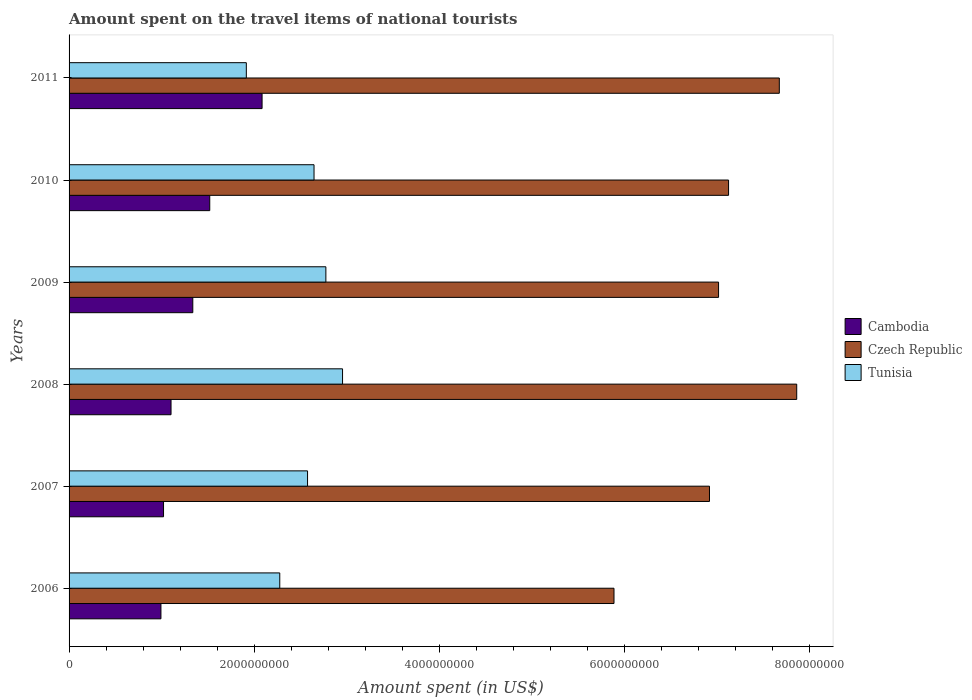How many groups of bars are there?
Ensure brevity in your answer.  6. Are the number of bars on each tick of the Y-axis equal?
Provide a short and direct response. Yes. What is the label of the 4th group of bars from the top?
Give a very brief answer. 2008. In how many cases, is the number of bars for a given year not equal to the number of legend labels?
Make the answer very short. 0. What is the amount spent on the travel items of national tourists in Tunisia in 2010?
Your answer should be compact. 2.64e+09. Across all years, what is the maximum amount spent on the travel items of national tourists in Czech Republic?
Your answer should be compact. 7.86e+09. Across all years, what is the minimum amount spent on the travel items of national tourists in Tunisia?
Your response must be concise. 1.91e+09. In which year was the amount spent on the travel items of national tourists in Tunisia maximum?
Your answer should be very brief. 2008. In which year was the amount spent on the travel items of national tourists in Czech Republic minimum?
Keep it short and to the point. 2006. What is the total amount spent on the travel items of national tourists in Tunisia in the graph?
Your answer should be compact. 1.51e+1. What is the difference between the amount spent on the travel items of national tourists in Tunisia in 2008 and that in 2009?
Your response must be concise. 1.80e+08. What is the difference between the amount spent on the travel items of national tourists in Czech Republic in 2006 and the amount spent on the travel items of national tourists in Tunisia in 2008?
Your response must be concise. 2.93e+09. What is the average amount spent on the travel items of national tourists in Cambodia per year?
Keep it short and to the point. 1.34e+09. In the year 2007, what is the difference between the amount spent on the travel items of national tourists in Cambodia and amount spent on the travel items of national tourists in Czech Republic?
Provide a succinct answer. -5.90e+09. In how many years, is the amount spent on the travel items of national tourists in Czech Republic greater than 4400000000 US$?
Your response must be concise. 6. What is the ratio of the amount spent on the travel items of national tourists in Cambodia in 2006 to that in 2011?
Your answer should be very brief. 0.48. What is the difference between the highest and the second highest amount spent on the travel items of national tourists in Cambodia?
Your answer should be compact. 5.65e+08. What is the difference between the highest and the lowest amount spent on the travel items of national tourists in Cambodia?
Provide a short and direct response. 1.09e+09. In how many years, is the amount spent on the travel items of national tourists in Czech Republic greater than the average amount spent on the travel items of national tourists in Czech Republic taken over all years?
Make the answer very short. 3. Is the sum of the amount spent on the travel items of national tourists in Czech Republic in 2008 and 2010 greater than the maximum amount spent on the travel items of national tourists in Tunisia across all years?
Offer a terse response. Yes. What does the 1st bar from the top in 2006 represents?
Your answer should be compact. Tunisia. What does the 3rd bar from the bottom in 2010 represents?
Make the answer very short. Tunisia. Are the values on the major ticks of X-axis written in scientific E-notation?
Provide a succinct answer. No. Where does the legend appear in the graph?
Your answer should be compact. Center right. How many legend labels are there?
Keep it short and to the point. 3. What is the title of the graph?
Provide a succinct answer. Amount spent on the travel items of national tourists. Does "Guatemala" appear as one of the legend labels in the graph?
Keep it short and to the point. No. What is the label or title of the X-axis?
Keep it short and to the point. Amount spent (in US$). What is the label or title of the Y-axis?
Give a very brief answer. Years. What is the Amount spent (in US$) of Cambodia in 2006?
Keep it short and to the point. 9.92e+08. What is the Amount spent (in US$) in Czech Republic in 2006?
Your response must be concise. 5.88e+09. What is the Amount spent (in US$) in Tunisia in 2006?
Your answer should be compact. 2.28e+09. What is the Amount spent (in US$) in Cambodia in 2007?
Provide a short and direct response. 1.02e+09. What is the Amount spent (in US$) of Czech Republic in 2007?
Keep it short and to the point. 6.92e+09. What is the Amount spent (in US$) in Tunisia in 2007?
Your answer should be compact. 2.58e+09. What is the Amount spent (in US$) in Cambodia in 2008?
Your answer should be compact. 1.10e+09. What is the Amount spent (in US$) in Czech Republic in 2008?
Provide a short and direct response. 7.86e+09. What is the Amount spent (in US$) of Tunisia in 2008?
Offer a very short reply. 2.95e+09. What is the Amount spent (in US$) in Cambodia in 2009?
Keep it short and to the point. 1.34e+09. What is the Amount spent (in US$) in Czech Republic in 2009?
Provide a short and direct response. 7.01e+09. What is the Amount spent (in US$) in Tunisia in 2009?
Make the answer very short. 2.77e+09. What is the Amount spent (in US$) of Cambodia in 2010?
Give a very brief answer. 1.52e+09. What is the Amount spent (in US$) of Czech Republic in 2010?
Ensure brevity in your answer.  7.12e+09. What is the Amount spent (in US$) of Tunisia in 2010?
Offer a very short reply. 2.64e+09. What is the Amount spent (in US$) of Cambodia in 2011?
Keep it short and to the point. 2.08e+09. What is the Amount spent (in US$) in Czech Republic in 2011?
Your answer should be compact. 7.67e+09. What is the Amount spent (in US$) of Tunisia in 2011?
Offer a very short reply. 1.91e+09. Across all years, what is the maximum Amount spent (in US$) of Cambodia?
Ensure brevity in your answer.  2.08e+09. Across all years, what is the maximum Amount spent (in US$) in Czech Republic?
Provide a succinct answer. 7.86e+09. Across all years, what is the maximum Amount spent (in US$) in Tunisia?
Ensure brevity in your answer.  2.95e+09. Across all years, what is the minimum Amount spent (in US$) in Cambodia?
Offer a terse response. 9.92e+08. Across all years, what is the minimum Amount spent (in US$) in Czech Republic?
Keep it short and to the point. 5.88e+09. Across all years, what is the minimum Amount spent (in US$) in Tunisia?
Provide a short and direct response. 1.91e+09. What is the total Amount spent (in US$) in Cambodia in the graph?
Make the answer very short. 8.05e+09. What is the total Amount spent (in US$) in Czech Republic in the graph?
Offer a terse response. 4.25e+1. What is the total Amount spent (in US$) of Tunisia in the graph?
Your answer should be very brief. 1.51e+1. What is the difference between the Amount spent (in US$) in Cambodia in 2006 and that in 2007?
Your answer should be compact. -2.80e+07. What is the difference between the Amount spent (in US$) in Czech Republic in 2006 and that in 2007?
Give a very brief answer. -1.03e+09. What is the difference between the Amount spent (in US$) of Tunisia in 2006 and that in 2007?
Your answer should be very brief. -3.00e+08. What is the difference between the Amount spent (in US$) in Cambodia in 2006 and that in 2008?
Provide a succinct answer. -1.09e+08. What is the difference between the Amount spent (in US$) of Czech Republic in 2006 and that in 2008?
Your response must be concise. -1.97e+09. What is the difference between the Amount spent (in US$) in Tunisia in 2006 and that in 2008?
Provide a succinct answer. -6.78e+08. What is the difference between the Amount spent (in US$) of Cambodia in 2006 and that in 2009?
Your answer should be compact. -3.44e+08. What is the difference between the Amount spent (in US$) in Czech Republic in 2006 and that in 2009?
Offer a terse response. -1.13e+09. What is the difference between the Amount spent (in US$) of Tunisia in 2006 and that in 2009?
Offer a very short reply. -4.98e+08. What is the difference between the Amount spent (in US$) of Cambodia in 2006 and that in 2010?
Ensure brevity in your answer.  -5.27e+08. What is the difference between the Amount spent (in US$) of Czech Republic in 2006 and that in 2010?
Offer a terse response. -1.24e+09. What is the difference between the Amount spent (in US$) in Tunisia in 2006 and that in 2010?
Keep it short and to the point. -3.70e+08. What is the difference between the Amount spent (in US$) of Cambodia in 2006 and that in 2011?
Your answer should be very brief. -1.09e+09. What is the difference between the Amount spent (in US$) of Czech Republic in 2006 and that in 2011?
Give a very brief answer. -1.78e+09. What is the difference between the Amount spent (in US$) in Tunisia in 2006 and that in 2011?
Your answer should be very brief. 3.61e+08. What is the difference between the Amount spent (in US$) of Cambodia in 2007 and that in 2008?
Your answer should be very brief. -8.10e+07. What is the difference between the Amount spent (in US$) of Czech Republic in 2007 and that in 2008?
Offer a very short reply. -9.42e+08. What is the difference between the Amount spent (in US$) of Tunisia in 2007 and that in 2008?
Provide a short and direct response. -3.78e+08. What is the difference between the Amount spent (in US$) in Cambodia in 2007 and that in 2009?
Your response must be concise. -3.16e+08. What is the difference between the Amount spent (in US$) of Czech Republic in 2007 and that in 2009?
Your response must be concise. -9.80e+07. What is the difference between the Amount spent (in US$) of Tunisia in 2007 and that in 2009?
Provide a short and direct response. -1.98e+08. What is the difference between the Amount spent (in US$) in Cambodia in 2007 and that in 2010?
Provide a succinct answer. -4.99e+08. What is the difference between the Amount spent (in US$) of Czech Republic in 2007 and that in 2010?
Offer a very short reply. -2.06e+08. What is the difference between the Amount spent (in US$) of Tunisia in 2007 and that in 2010?
Provide a succinct answer. -7.00e+07. What is the difference between the Amount spent (in US$) of Cambodia in 2007 and that in 2011?
Your answer should be compact. -1.06e+09. What is the difference between the Amount spent (in US$) in Czech Republic in 2007 and that in 2011?
Your answer should be very brief. -7.54e+08. What is the difference between the Amount spent (in US$) of Tunisia in 2007 and that in 2011?
Your response must be concise. 6.61e+08. What is the difference between the Amount spent (in US$) in Cambodia in 2008 and that in 2009?
Keep it short and to the point. -2.35e+08. What is the difference between the Amount spent (in US$) in Czech Republic in 2008 and that in 2009?
Make the answer very short. 8.44e+08. What is the difference between the Amount spent (in US$) of Tunisia in 2008 and that in 2009?
Offer a terse response. 1.80e+08. What is the difference between the Amount spent (in US$) in Cambodia in 2008 and that in 2010?
Offer a very short reply. -4.18e+08. What is the difference between the Amount spent (in US$) of Czech Republic in 2008 and that in 2010?
Your response must be concise. 7.36e+08. What is the difference between the Amount spent (in US$) of Tunisia in 2008 and that in 2010?
Ensure brevity in your answer.  3.08e+08. What is the difference between the Amount spent (in US$) in Cambodia in 2008 and that in 2011?
Make the answer very short. -9.83e+08. What is the difference between the Amount spent (in US$) in Czech Republic in 2008 and that in 2011?
Give a very brief answer. 1.88e+08. What is the difference between the Amount spent (in US$) in Tunisia in 2008 and that in 2011?
Your answer should be very brief. 1.04e+09. What is the difference between the Amount spent (in US$) of Cambodia in 2009 and that in 2010?
Give a very brief answer. -1.83e+08. What is the difference between the Amount spent (in US$) of Czech Republic in 2009 and that in 2010?
Ensure brevity in your answer.  -1.08e+08. What is the difference between the Amount spent (in US$) of Tunisia in 2009 and that in 2010?
Offer a very short reply. 1.28e+08. What is the difference between the Amount spent (in US$) of Cambodia in 2009 and that in 2011?
Make the answer very short. -7.48e+08. What is the difference between the Amount spent (in US$) in Czech Republic in 2009 and that in 2011?
Provide a succinct answer. -6.56e+08. What is the difference between the Amount spent (in US$) in Tunisia in 2009 and that in 2011?
Offer a very short reply. 8.59e+08. What is the difference between the Amount spent (in US$) of Cambodia in 2010 and that in 2011?
Provide a succinct answer. -5.65e+08. What is the difference between the Amount spent (in US$) of Czech Republic in 2010 and that in 2011?
Offer a very short reply. -5.48e+08. What is the difference between the Amount spent (in US$) in Tunisia in 2010 and that in 2011?
Make the answer very short. 7.31e+08. What is the difference between the Amount spent (in US$) in Cambodia in 2006 and the Amount spent (in US$) in Czech Republic in 2007?
Provide a succinct answer. -5.92e+09. What is the difference between the Amount spent (in US$) in Cambodia in 2006 and the Amount spent (in US$) in Tunisia in 2007?
Offer a very short reply. -1.58e+09. What is the difference between the Amount spent (in US$) in Czech Republic in 2006 and the Amount spent (in US$) in Tunisia in 2007?
Ensure brevity in your answer.  3.31e+09. What is the difference between the Amount spent (in US$) in Cambodia in 2006 and the Amount spent (in US$) in Czech Republic in 2008?
Ensure brevity in your answer.  -6.86e+09. What is the difference between the Amount spent (in US$) of Cambodia in 2006 and the Amount spent (in US$) of Tunisia in 2008?
Give a very brief answer. -1.96e+09. What is the difference between the Amount spent (in US$) in Czech Republic in 2006 and the Amount spent (in US$) in Tunisia in 2008?
Your answer should be compact. 2.93e+09. What is the difference between the Amount spent (in US$) of Cambodia in 2006 and the Amount spent (in US$) of Czech Republic in 2009?
Give a very brief answer. -6.02e+09. What is the difference between the Amount spent (in US$) in Cambodia in 2006 and the Amount spent (in US$) in Tunisia in 2009?
Keep it short and to the point. -1.78e+09. What is the difference between the Amount spent (in US$) of Czech Republic in 2006 and the Amount spent (in US$) of Tunisia in 2009?
Your response must be concise. 3.11e+09. What is the difference between the Amount spent (in US$) of Cambodia in 2006 and the Amount spent (in US$) of Czech Republic in 2010?
Provide a short and direct response. -6.13e+09. What is the difference between the Amount spent (in US$) in Cambodia in 2006 and the Amount spent (in US$) in Tunisia in 2010?
Provide a succinct answer. -1.65e+09. What is the difference between the Amount spent (in US$) in Czech Republic in 2006 and the Amount spent (in US$) in Tunisia in 2010?
Offer a very short reply. 3.24e+09. What is the difference between the Amount spent (in US$) of Cambodia in 2006 and the Amount spent (in US$) of Czech Republic in 2011?
Your answer should be compact. -6.68e+09. What is the difference between the Amount spent (in US$) in Cambodia in 2006 and the Amount spent (in US$) in Tunisia in 2011?
Offer a terse response. -9.22e+08. What is the difference between the Amount spent (in US$) of Czech Republic in 2006 and the Amount spent (in US$) of Tunisia in 2011?
Provide a short and direct response. 3.97e+09. What is the difference between the Amount spent (in US$) of Cambodia in 2007 and the Amount spent (in US$) of Czech Republic in 2008?
Your answer should be very brief. -6.84e+09. What is the difference between the Amount spent (in US$) in Cambodia in 2007 and the Amount spent (in US$) in Tunisia in 2008?
Ensure brevity in your answer.  -1.93e+09. What is the difference between the Amount spent (in US$) in Czech Republic in 2007 and the Amount spent (in US$) in Tunisia in 2008?
Your answer should be compact. 3.96e+09. What is the difference between the Amount spent (in US$) of Cambodia in 2007 and the Amount spent (in US$) of Czech Republic in 2009?
Ensure brevity in your answer.  -5.99e+09. What is the difference between the Amount spent (in US$) of Cambodia in 2007 and the Amount spent (in US$) of Tunisia in 2009?
Your answer should be compact. -1.75e+09. What is the difference between the Amount spent (in US$) of Czech Republic in 2007 and the Amount spent (in US$) of Tunisia in 2009?
Your answer should be compact. 4.14e+09. What is the difference between the Amount spent (in US$) of Cambodia in 2007 and the Amount spent (in US$) of Czech Republic in 2010?
Offer a terse response. -6.10e+09. What is the difference between the Amount spent (in US$) of Cambodia in 2007 and the Amount spent (in US$) of Tunisia in 2010?
Offer a very short reply. -1.62e+09. What is the difference between the Amount spent (in US$) in Czech Republic in 2007 and the Amount spent (in US$) in Tunisia in 2010?
Offer a terse response. 4.27e+09. What is the difference between the Amount spent (in US$) in Cambodia in 2007 and the Amount spent (in US$) in Czech Republic in 2011?
Provide a short and direct response. -6.65e+09. What is the difference between the Amount spent (in US$) in Cambodia in 2007 and the Amount spent (in US$) in Tunisia in 2011?
Make the answer very short. -8.94e+08. What is the difference between the Amount spent (in US$) of Czech Republic in 2007 and the Amount spent (in US$) of Tunisia in 2011?
Offer a very short reply. 5.00e+09. What is the difference between the Amount spent (in US$) in Cambodia in 2008 and the Amount spent (in US$) in Czech Republic in 2009?
Your answer should be compact. -5.91e+09. What is the difference between the Amount spent (in US$) in Cambodia in 2008 and the Amount spent (in US$) in Tunisia in 2009?
Your answer should be compact. -1.67e+09. What is the difference between the Amount spent (in US$) of Czech Republic in 2008 and the Amount spent (in US$) of Tunisia in 2009?
Make the answer very short. 5.08e+09. What is the difference between the Amount spent (in US$) of Cambodia in 2008 and the Amount spent (in US$) of Czech Republic in 2010?
Your answer should be compact. -6.02e+09. What is the difference between the Amount spent (in US$) of Cambodia in 2008 and the Amount spent (in US$) of Tunisia in 2010?
Your answer should be very brief. -1.54e+09. What is the difference between the Amount spent (in US$) of Czech Republic in 2008 and the Amount spent (in US$) of Tunisia in 2010?
Offer a terse response. 5.21e+09. What is the difference between the Amount spent (in US$) of Cambodia in 2008 and the Amount spent (in US$) of Czech Republic in 2011?
Make the answer very short. -6.57e+09. What is the difference between the Amount spent (in US$) in Cambodia in 2008 and the Amount spent (in US$) in Tunisia in 2011?
Give a very brief answer. -8.13e+08. What is the difference between the Amount spent (in US$) in Czech Republic in 2008 and the Amount spent (in US$) in Tunisia in 2011?
Your answer should be very brief. 5.94e+09. What is the difference between the Amount spent (in US$) of Cambodia in 2009 and the Amount spent (in US$) of Czech Republic in 2010?
Give a very brief answer. -5.78e+09. What is the difference between the Amount spent (in US$) in Cambodia in 2009 and the Amount spent (in US$) in Tunisia in 2010?
Make the answer very short. -1.31e+09. What is the difference between the Amount spent (in US$) in Czech Republic in 2009 and the Amount spent (in US$) in Tunisia in 2010?
Ensure brevity in your answer.  4.37e+09. What is the difference between the Amount spent (in US$) in Cambodia in 2009 and the Amount spent (in US$) in Czech Republic in 2011?
Offer a terse response. -6.33e+09. What is the difference between the Amount spent (in US$) in Cambodia in 2009 and the Amount spent (in US$) in Tunisia in 2011?
Ensure brevity in your answer.  -5.78e+08. What is the difference between the Amount spent (in US$) of Czech Republic in 2009 and the Amount spent (in US$) of Tunisia in 2011?
Make the answer very short. 5.10e+09. What is the difference between the Amount spent (in US$) in Cambodia in 2010 and the Amount spent (in US$) in Czech Republic in 2011?
Your response must be concise. -6.15e+09. What is the difference between the Amount spent (in US$) in Cambodia in 2010 and the Amount spent (in US$) in Tunisia in 2011?
Offer a very short reply. -3.95e+08. What is the difference between the Amount spent (in US$) in Czech Republic in 2010 and the Amount spent (in US$) in Tunisia in 2011?
Your answer should be compact. 5.21e+09. What is the average Amount spent (in US$) of Cambodia per year?
Offer a very short reply. 1.34e+09. What is the average Amount spent (in US$) of Czech Republic per year?
Make the answer very short. 7.08e+09. What is the average Amount spent (in US$) in Tunisia per year?
Provide a short and direct response. 2.52e+09. In the year 2006, what is the difference between the Amount spent (in US$) of Cambodia and Amount spent (in US$) of Czech Republic?
Offer a terse response. -4.89e+09. In the year 2006, what is the difference between the Amount spent (in US$) of Cambodia and Amount spent (in US$) of Tunisia?
Your answer should be very brief. -1.28e+09. In the year 2006, what is the difference between the Amount spent (in US$) in Czech Republic and Amount spent (in US$) in Tunisia?
Your answer should be very brief. 3.61e+09. In the year 2007, what is the difference between the Amount spent (in US$) of Cambodia and Amount spent (in US$) of Czech Republic?
Ensure brevity in your answer.  -5.90e+09. In the year 2007, what is the difference between the Amount spent (in US$) in Cambodia and Amount spent (in US$) in Tunisia?
Ensure brevity in your answer.  -1.56e+09. In the year 2007, what is the difference between the Amount spent (in US$) in Czech Republic and Amount spent (in US$) in Tunisia?
Your answer should be very brief. 4.34e+09. In the year 2008, what is the difference between the Amount spent (in US$) in Cambodia and Amount spent (in US$) in Czech Republic?
Your response must be concise. -6.76e+09. In the year 2008, what is the difference between the Amount spent (in US$) of Cambodia and Amount spent (in US$) of Tunisia?
Provide a succinct answer. -1.85e+09. In the year 2008, what is the difference between the Amount spent (in US$) of Czech Republic and Amount spent (in US$) of Tunisia?
Keep it short and to the point. 4.90e+09. In the year 2009, what is the difference between the Amount spent (in US$) in Cambodia and Amount spent (in US$) in Czech Republic?
Ensure brevity in your answer.  -5.68e+09. In the year 2009, what is the difference between the Amount spent (in US$) of Cambodia and Amount spent (in US$) of Tunisia?
Give a very brief answer. -1.44e+09. In the year 2009, what is the difference between the Amount spent (in US$) of Czech Republic and Amount spent (in US$) of Tunisia?
Offer a terse response. 4.24e+09. In the year 2010, what is the difference between the Amount spent (in US$) in Cambodia and Amount spent (in US$) in Czech Republic?
Your response must be concise. -5.60e+09. In the year 2010, what is the difference between the Amount spent (in US$) of Cambodia and Amount spent (in US$) of Tunisia?
Offer a terse response. -1.13e+09. In the year 2010, what is the difference between the Amount spent (in US$) in Czech Republic and Amount spent (in US$) in Tunisia?
Make the answer very short. 4.48e+09. In the year 2011, what is the difference between the Amount spent (in US$) of Cambodia and Amount spent (in US$) of Czech Republic?
Offer a very short reply. -5.58e+09. In the year 2011, what is the difference between the Amount spent (in US$) of Cambodia and Amount spent (in US$) of Tunisia?
Your answer should be compact. 1.70e+08. In the year 2011, what is the difference between the Amount spent (in US$) in Czech Republic and Amount spent (in US$) in Tunisia?
Your response must be concise. 5.76e+09. What is the ratio of the Amount spent (in US$) in Cambodia in 2006 to that in 2007?
Provide a succinct answer. 0.97. What is the ratio of the Amount spent (in US$) in Czech Republic in 2006 to that in 2007?
Offer a very short reply. 0.85. What is the ratio of the Amount spent (in US$) of Tunisia in 2006 to that in 2007?
Your response must be concise. 0.88. What is the ratio of the Amount spent (in US$) of Cambodia in 2006 to that in 2008?
Your response must be concise. 0.9. What is the ratio of the Amount spent (in US$) in Czech Republic in 2006 to that in 2008?
Provide a succinct answer. 0.75. What is the ratio of the Amount spent (in US$) in Tunisia in 2006 to that in 2008?
Make the answer very short. 0.77. What is the ratio of the Amount spent (in US$) in Cambodia in 2006 to that in 2009?
Keep it short and to the point. 0.74. What is the ratio of the Amount spent (in US$) of Czech Republic in 2006 to that in 2009?
Provide a succinct answer. 0.84. What is the ratio of the Amount spent (in US$) in Tunisia in 2006 to that in 2009?
Your response must be concise. 0.82. What is the ratio of the Amount spent (in US$) of Cambodia in 2006 to that in 2010?
Make the answer very short. 0.65. What is the ratio of the Amount spent (in US$) in Czech Republic in 2006 to that in 2010?
Your answer should be compact. 0.83. What is the ratio of the Amount spent (in US$) in Tunisia in 2006 to that in 2010?
Give a very brief answer. 0.86. What is the ratio of the Amount spent (in US$) in Cambodia in 2006 to that in 2011?
Ensure brevity in your answer.  0.48. What is the ratio of the Amount spent (in US$) of Czech Republic in 2006 to that in 2011?
Your answer should be very brief. 0.77. What is the ratio of the Amount spent (in US$) in Tunisia in 2006 to that in 2011?
Your answer should be compact. 1.19. What is the ratio of the Amount spent (in US$) of Cambodia in 2007 to that in 2008?
Your response must be concise. 0.93. What is the ratio of the Amount spent (in US$) in Czech Republic in 2007 to that in 2008?
Your answer should be very brief. 0.88. What is the ratio of the Amount spent (in US$) in Tunisia in 2007 to that in 2008?
Make the answer very short. 0.87. What is the ratio of the Amount spent (in US$) of Cambodia in 2007 to that in 2009?
Provide a succinct answer. 0.76. What is the ratio of the Amount spent (in US$) of Czech Republic in 2007 to that in 2009?
Provide a succinct answer. 0.99. What is the ratio of the Amount spent (in US$) in Cambodia in 2007 to that in 2010?
Offer a very short reply. 0.67. What is the ratio of the Amount spent (in US$) of Czech Republic in 2007 to that in 2010?
Your answer should be very brief. 0.97. What is the ratio of the Amount spent (in US$) in Tunisia in 2007 to that in 2010?
Your answer should be very brief. 0.97. What is the ratio of the Amount spent (in US$) of Cambodia in 2007 to that in 2011?
Provide a short and direct response. 0.49. What is the ratio of the Amount spent (in US$) in Czech Republic in 2007 to that in 2011?
Ensure brevity in your answer.  0.9. What is the ratio of the Amount spent (in US$) in Tunisia in 2007 to that in 2011?
Your answer should be very brief. 1.35. What is the ratio of the Amount spent (in US$) of Cambodia in 2008 to that in 2009?
Provide a short and direct response. 0.82. What is the ratio of the Amount spent (in US$) in Czech Republic in 2008 to that in 2009?
Provide a short and direct response. 1.12. What is the ratio of the Amount spent (in US$) of Tunisia in 2008 to that in 2009?
Your answer should be very brief. 1.06. What is the ratio of the Amount spent (in US$) in Cambodia in 2008 to that in 2010?
Give a very brief answer. 0.72. What is the ratio of the Amount spent (in US$) in Czech Republic in 2008 to that in 2010?
Offer a very short reply. 1.1. What is the ratio of the Amount spent (in US$) in Tunisia in 2008 to that in 2010?
Make the answer very short. 1.12. What is the ratio of the Amount spent (in US$) in Cambodia in 2008 to that in 2011?
Your answer should be very brief. 0.53. What is the ratio of the Amount spent (in US$) of Czech Republic in 2008 to that in 2011?
Your answer should be compact. 1.02. What is the ratio of the Amount spent (in US$) in Tunisia in 2008 to that in 2011?
Give a very brief answer. 1.54. What is the ratio of the Amount spent (in US$) of Cambodia in 2009 to that in 2010?
Offer a terse response. 0.88. What is the ratio of the Amount spent (in US$) of Czech Republic in 2009 to that in 2010?
Make the answer very short. 0.98. What is the ratio of the Amount spent (in US$) in Tunisia in 2009 to that in 2010?
Give a very brief answer. 1.05. What is the ratio of the Amount spent (in US$) in Cambodia in 2009 to that in 2011?
Provide a short and direct response. 0.64. What is the ratio of the Amount spent (in US$) of Czech Republic in 2009 to that in 2011?
Your response must be concise. 0.91. What is the ratio of the Amount spent (in US$) of Tunisia in 2009 to that in 2011?
Your response must be concise. 1.45. What is the ratio of the Amount spent (in US$) in Cambodia in 2010 to that in 2011?
Your answer should be very brief. 0.73. What is the ratio of the Amount spent (in US$) of Czech Republic in 2010 to that in 2011?
Your response must be concise. 0.93. What is the ratio of the Amount spent (in US$) of Tunisia in 2010 to that in 2011?
Keep it short and to the point. 1.38. What is the difference between the highest and the second highest Amount spent (in US$) in Cambodia?
Offer a terse response. 5.65e+08. What is the difference between the highest and the second highest Amount spent (in US$) in Czech Republic?
Offer a very short reply. 1.88e+08. What is the difference between the highest and the second highest Amount spent (in US$) in Tunisia?
Provide a succinct answer. 1.80e+08. What is the difference between the highest and the lowest Amount spent (in US$) of Cambodia?
Your response must be concise. 1.09e+09. What is the difference between the highest and the lowest Amount spent (in US$) of Czech Republic?
Offer a terse response. 1.97e+09. What is the difference between the highest and the lowest Amount spent (in US$) in Tunisia?
Offer a very short reply. 1.04e+09. 